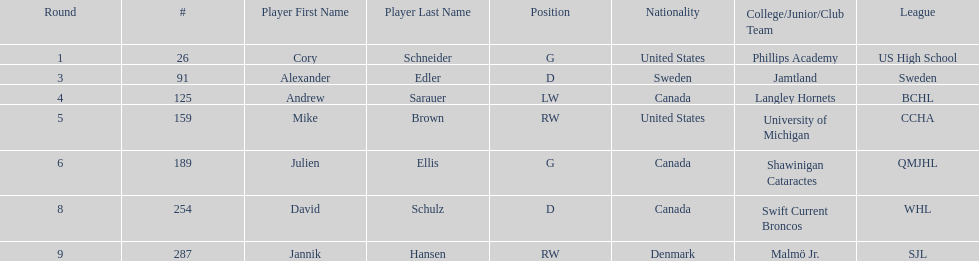What is the name of the last player on this chart? Jannik Hansen (RW). 